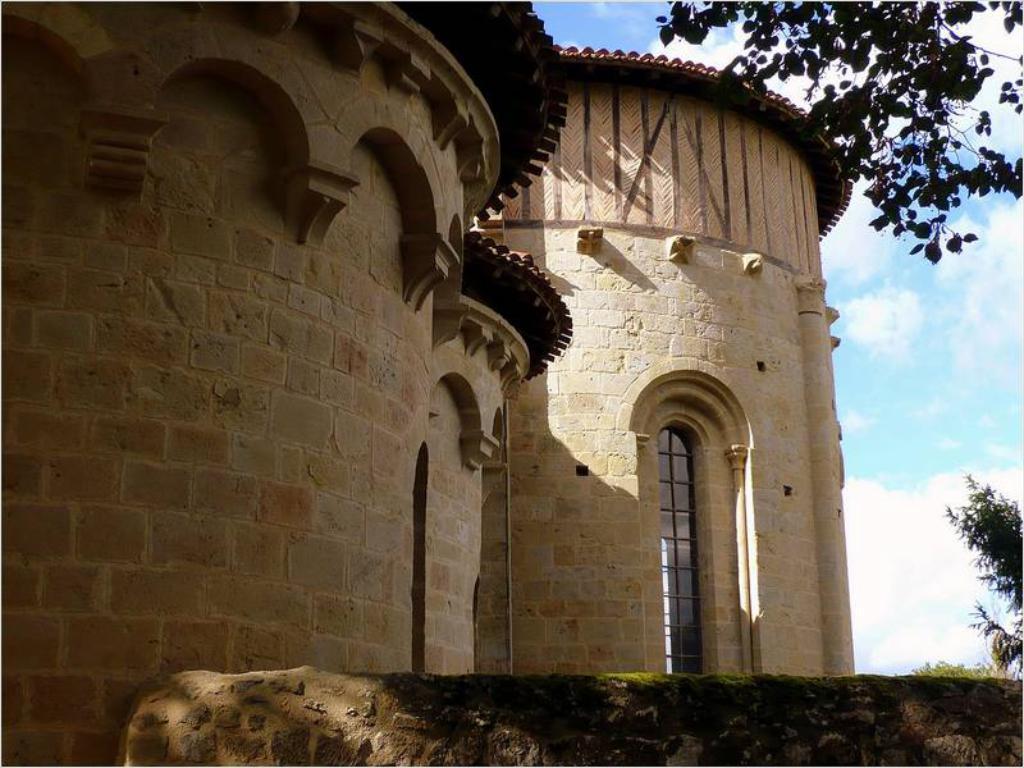In one or two sentences, can you explain what this image depicts? In this image there is a building. In front of the building there are trees. In the background there is the sky. 